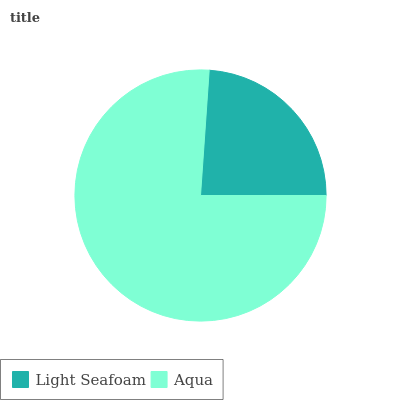Is Light Seafoam the minimum?
Answer yes or no. Yes. Is Aqua the maximum?
Answer yes or no. Yes. Is Aqua the minimum?
Answer yes or no. No. Is Aqua greater than Light Seafoam?
Answer yes or no. Yes. Is Light Seafoam less than Aqua?
Answer yes or no. Yes. Is Light Seafoam greater than Aqua?
Answer yes or no. No. Is Aqua less than Light Seafoam?
Answer yes or no. No. Is Aqua the high median?
Answer yes or no. Yes. Is Light Seafoam the low median?
Answer yes or no. Yes. Is Light Seafoam the high median?
Answer yes or no. No. Is Aqua the low median?
Answer yes or no. No. 